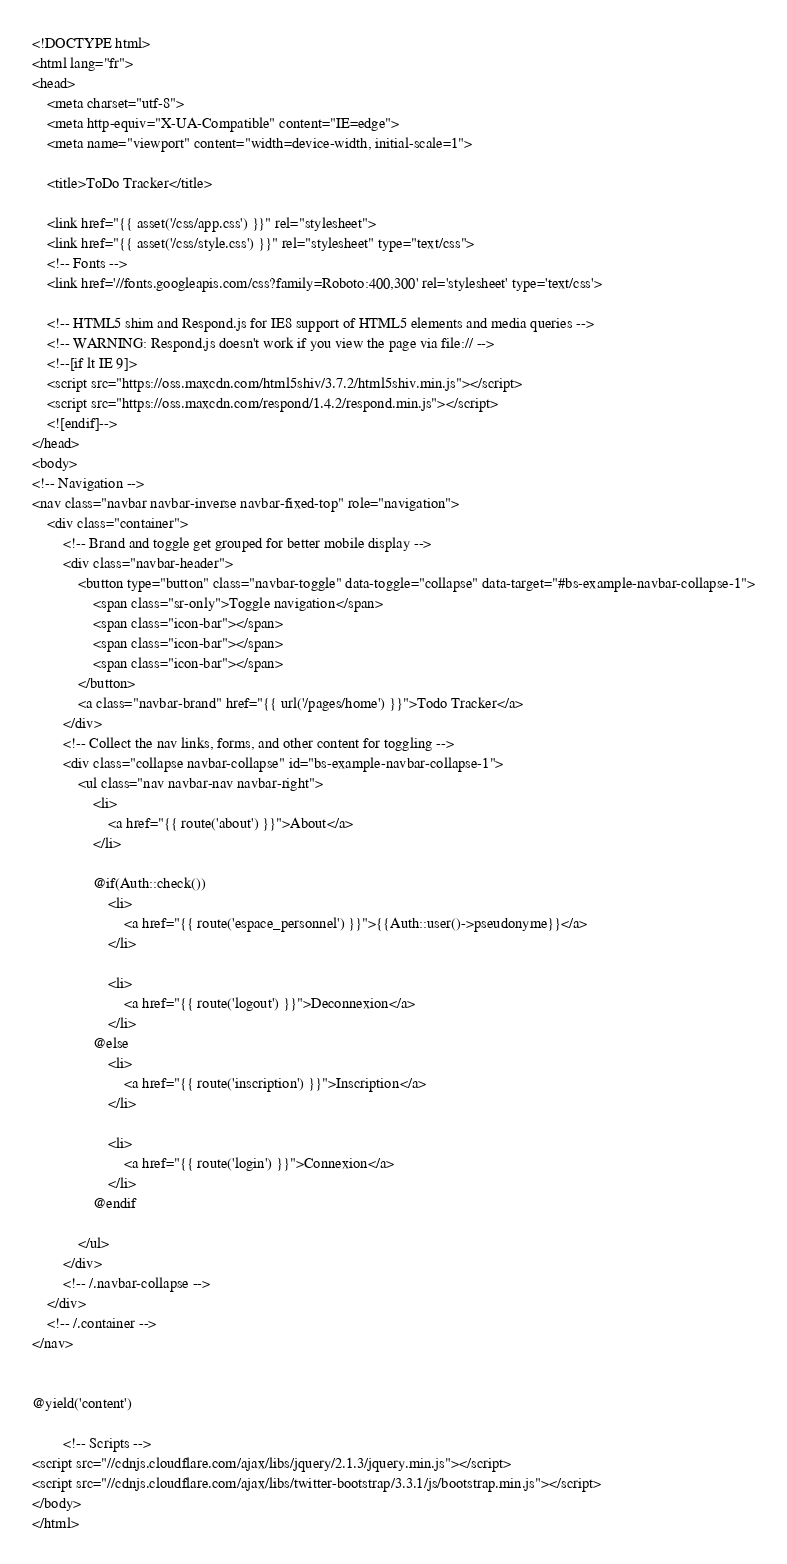Convert code to text. <code><loc_0><loc_0><loc_500><loc_500><_PHP_><!DOCTYPE html>
<html lang="fr">
<head>
    <meta charset="utf-8">
    <meta http-equiv="X-UA-Compatible" content="IE=edge">
    <meta name="viewport" content="width=device-width, initial-scale=1">

    <title>ToDo Tracker</title>

    <link href="{{ asset('/css/app.css') }}" rel="stylesheet">
    <link href="{{ asset('/css/style.css') }}" rel="stylesheet" type="text/css">
    <!-- Fonts -->
    <link href='//fonts.googleapis.com/css?family=Roboto:400,300' rel='stylesheet' type='text/css'>

    <!-- HTML5 shim and Respond.js for IE8 support of HTML5 elements and media queries -->
    <!-- WARNING: Respond.js doesn't work if you view the page via file:// -->
    <!--[if lt IE 9]>
    <script src="https://oss.maxcdn.com/html5shiv/3.7.2/html5shiv.min.js"></script>
    <script src="https://oss.maxcdn.com/respond/1.4.2/respond.min.js"></script>
    <![endif]-->
</head>
<body>
<!-- Navigation -->
<nav class="navbar navbar-inverse navbar-fixed-top" role="navigation">
    <div class="container">
        <!-- Brand and toggle get grouped for better mobile display -->
        <div class="navbar-header">
            <button type="button" class="navbar-toggle" data-toggle="collapse" data-target="#bs-example-navbar-collapse-1">
                <span class="sr-only">Toggle navigation</span>
                <span class="icon-bar"></span>
                <span class="icon-bar"></span>
                <span class="icon-bar"></span>
            </button>
            <a class="navbar-brand" href="{{ url('/pages/home') }}">Todo Tracker</a>
        </div>
        <!-- Collect the nav links, forms, and other content for toggling -->
        <div class="collapse navbar-collapse" id="bs-example-navbar-collapse-1">
            <ul class="nav navbar-nav navbar-right">
                <li>
                    <a href="{{ route('about') }}">About</a>
                </li>

                @if(Auth::check())
                    <li>
                        <a href="{{ route('espace_personnel') }}">{{Auth::user()->pseudonyme}}</a>
                    </li>

                    <li>
                        <a href="{{ route('logout') }}">Deconnexion</a>
                    </li>
                @else
                    <li>
                        <a href="{{ route('inscription') }}">Inscription</a>
                    </li>

                    <li>
                        <a href="{{ route('login') }}">Connexion</a>
                    </li>
                @endif

            </ul>
        </div>
        <!-- /.navbar-collapse -->
    </div>
    <!-- /.container -->
</nav>


@yield('content')

        <!-- Scripts -->
<script src="//cdnjs.cloudflare.com/ajax/libs/jquery/2.1.3/jquery.min.js"></script>
<script src="//cdnjs.cloudflare.com/ajax/libs/twitter-bootstrap/3.3.1/js/bootstrap.min.js"></script>
</body>
</html>
</code> 